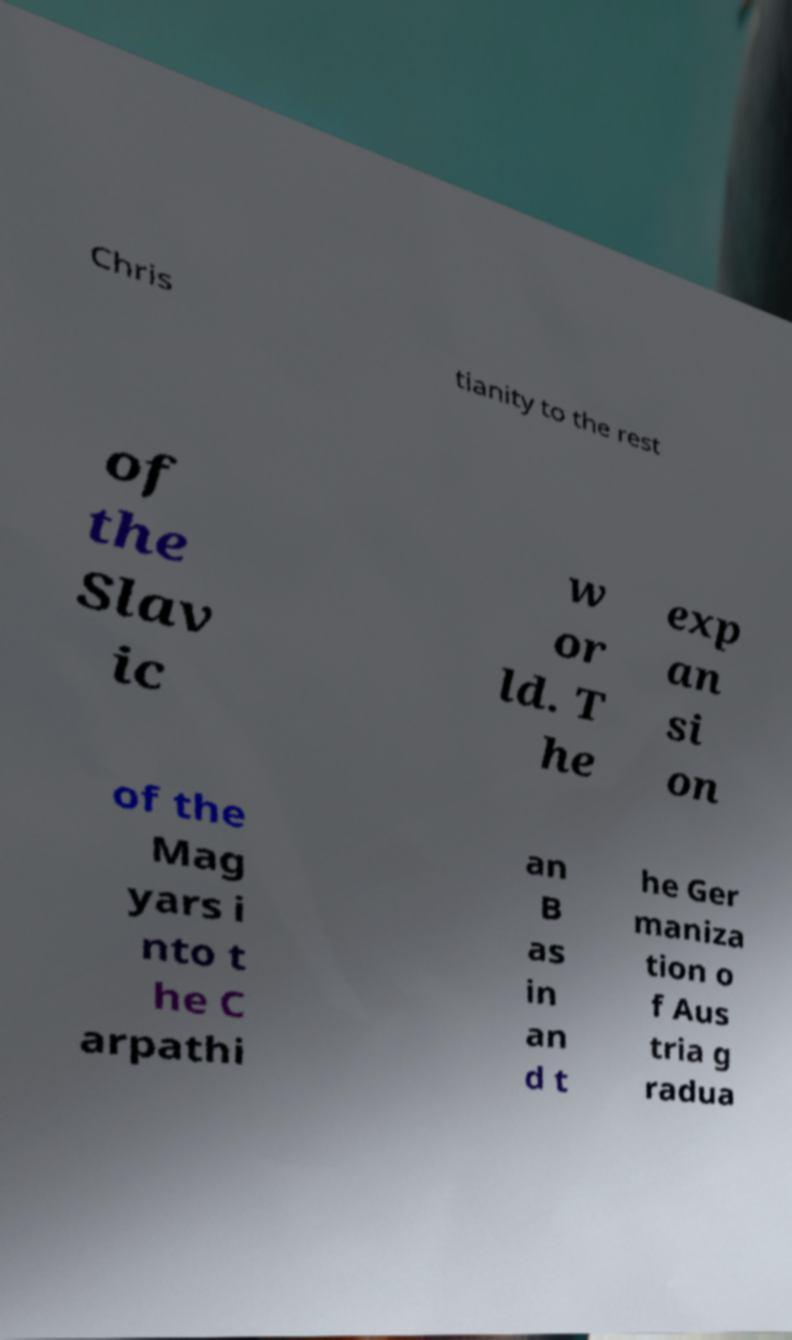Can you read and provide the text displayed in the image?This photo seems to have some interesting text. Can you extract and type it out for me? Chris tianity to the rest of the Slav ic w or ld. T he exp an si on of the Mag yars i nto t he C arpathi an B as in an d t he Ger maniza tion o f Aus tria g radua 